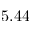Convert formula to latex. <formula><loc_0><loc_0><loc_500><loc_500>5 . 4 4</formula> 